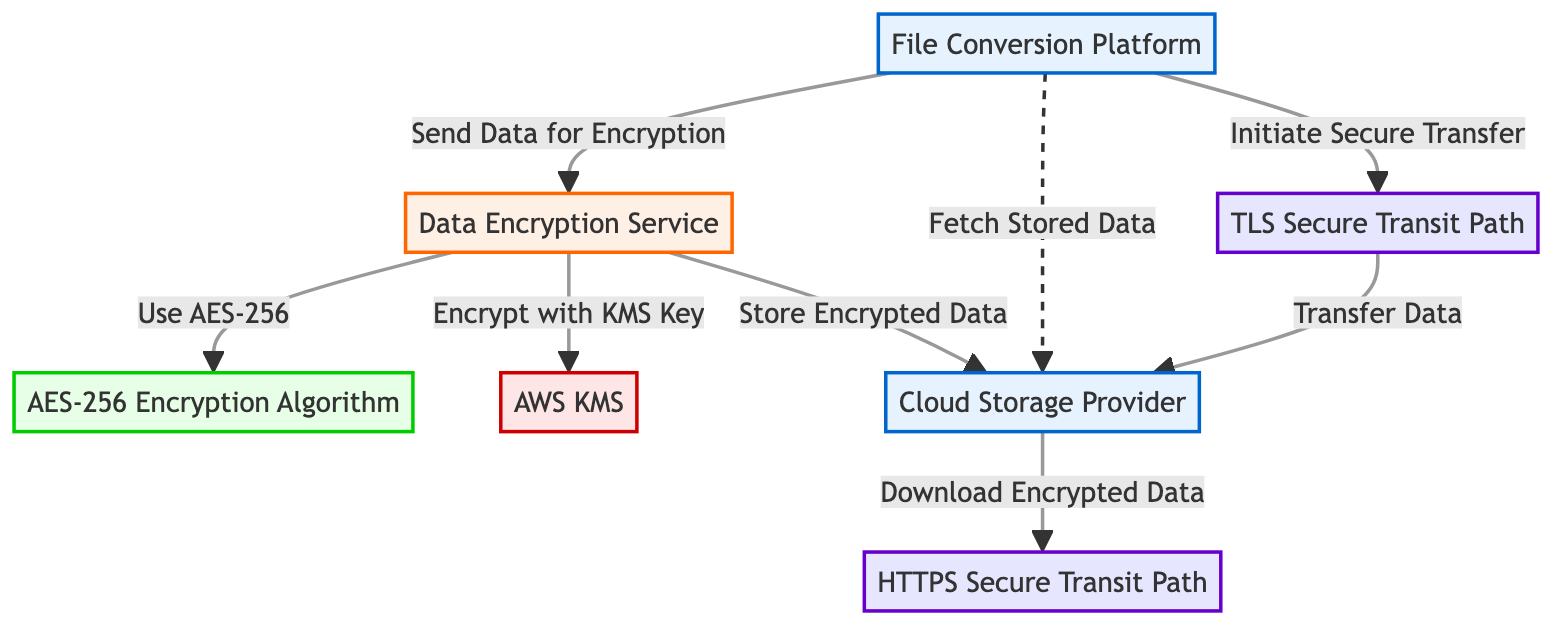What is the total number of nodes in the diagram? The diagram consists of 7 nodes, which are the Cloud Storage Provider, File Conversion Platform, Data Encryption Service, AES-256 Encryption Algorithm, AWS KMS, TLS Secure Transit Path, and HTTPS Secure Transit Path.
Answer: 7 What edge connects the File Conversion Platform to the Data Encryption Service? The edge connecting the File Conversion Platform to the Data Encryption Service is labeled "Send Data for Encryption," indicating the action of sending data for encryption.
Answer: Send Data for Encryption How many secure transit paths are shown in the diagram? There are two secure transit paths illustrated in the diagram: the TLS Secure Transit Path and the HTTPS Secure Transit Path.
Answer: 2 What encrypting algorithm is used in the Data Encryption Service? The Data Encryption Service uses the AES-256 Encryption Algorithm, as indicated by the flow marked "Use AES-256."
Answer: AES-256 Encryption Algorithm Which service is responsible for managing encryption keys? The AWS KMS (Key Management Service) is responsible for managing encryption keys, as indicated by the edge labeled "Encrypt with KMS Key."
Answer: AWS KMS What is the flow of data from the File Conversion Platform to the Cloud Storage Provider? The data flow begins at the File Conversion Platform, where data is sent for encryption to the Data Encryption Service, which then encrypts the data using the AWS KMS and finally stores the encrypted data in the Cloud Storage Provider.
Answer: Send Data for Encryption → Use AES-256 → Encrypt with KMS Key → Store Encrypted Data What type of connection is used for transferring data to the Cloud Storage Provider? The data is transferred to the Cloud Storage Provider using a TLS Secure Transit Path, represented in the diagram by an edge labeled "Transfer Data."
Answer: TLS Secure Transit Path Which node is connected to the HTTPS Secure Transit Path? The Cloud Storage Provider is connected to the HTTPS Secure Transit Path for downloading encrypted data, as shown in the edge labeled "Download Encrypted Data."
Answer: Cloud Storage Provider 